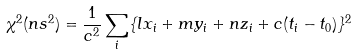<formula> <loc_0><loc_0><loc_500><loc_500>\chi ^ { 2 } ( n s ^ { 2 } ) = \frac { 1 } { c ^ { 2 } } \sum _ { i } \{ l x _ { i } + m y _ { i } + n z _ { i } + c ( t _ { i } - t _ { 0 } ) \} ^ { 2 }</formula> 